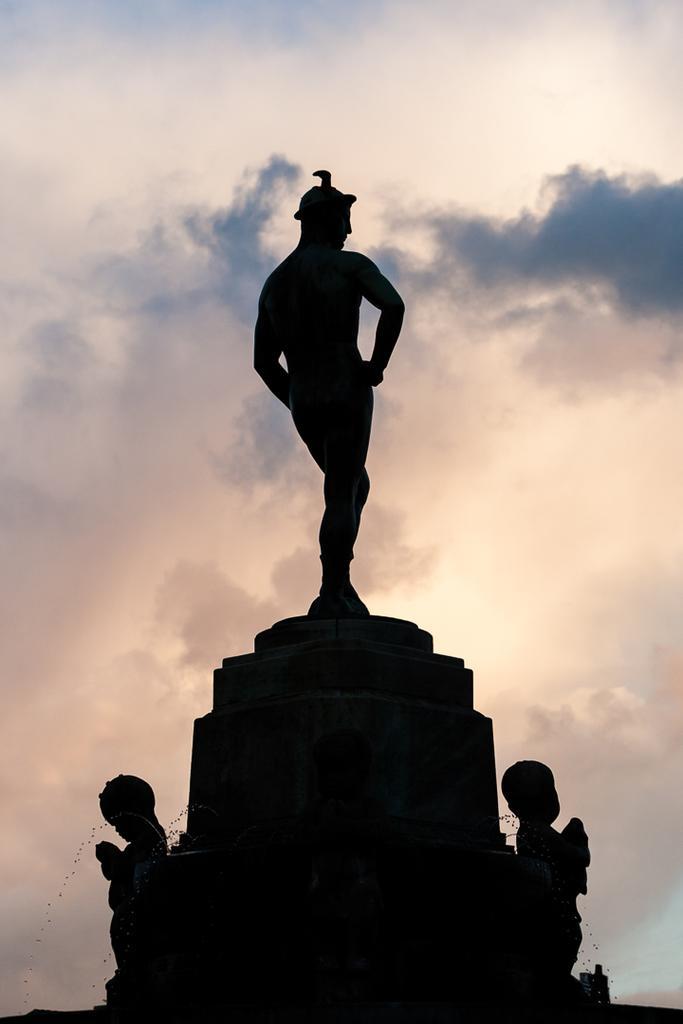Could you give a brief overview of what you see in this image? In this picture I can see the statue. I can see clouds in the sky. 